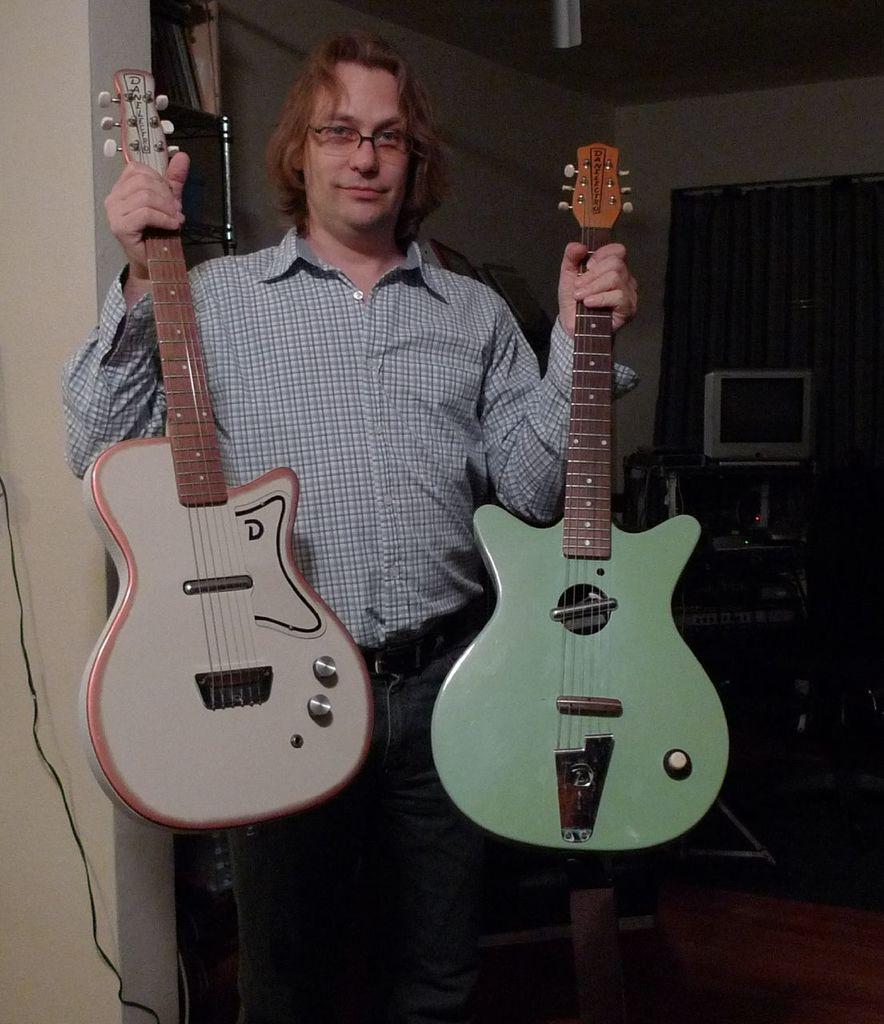Could you give a brief overview of what you see in this image? In this picture we can see a man, he is holding guitars in his hands and he wore spectacles, in the background we can see a television on the table, and also we can see curtains. 